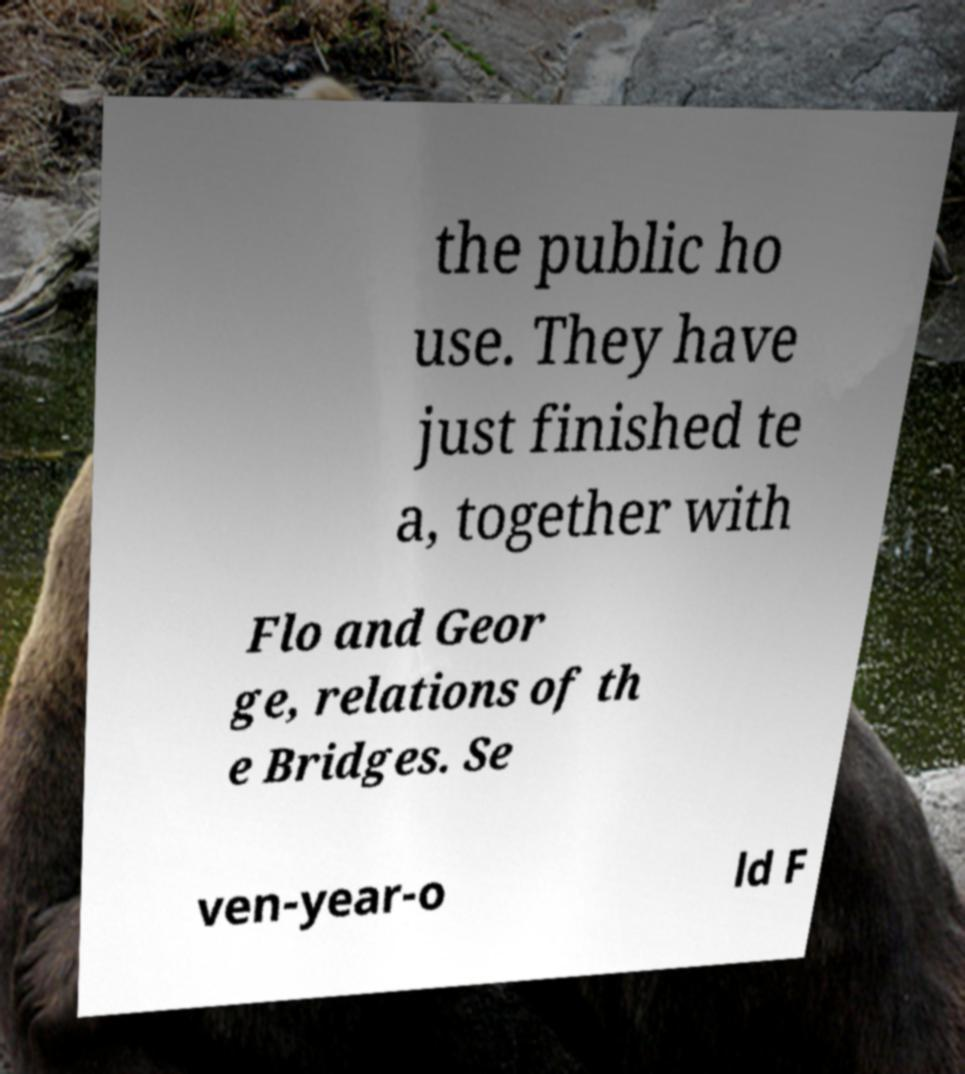Can you accurately transcribe the text from the provided image for me? the public ho use. They have just finished te a, together with Flo and Geor ge, relations of th e Bridges. Se ven-year-o ld F 